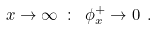Convert formula to latex. <formula><loc_0><loc_0><loc_500><loc_500>x \to \infty \ \colon \ \phi ^ { + } _ { x } \to 0 \ .</formula> 